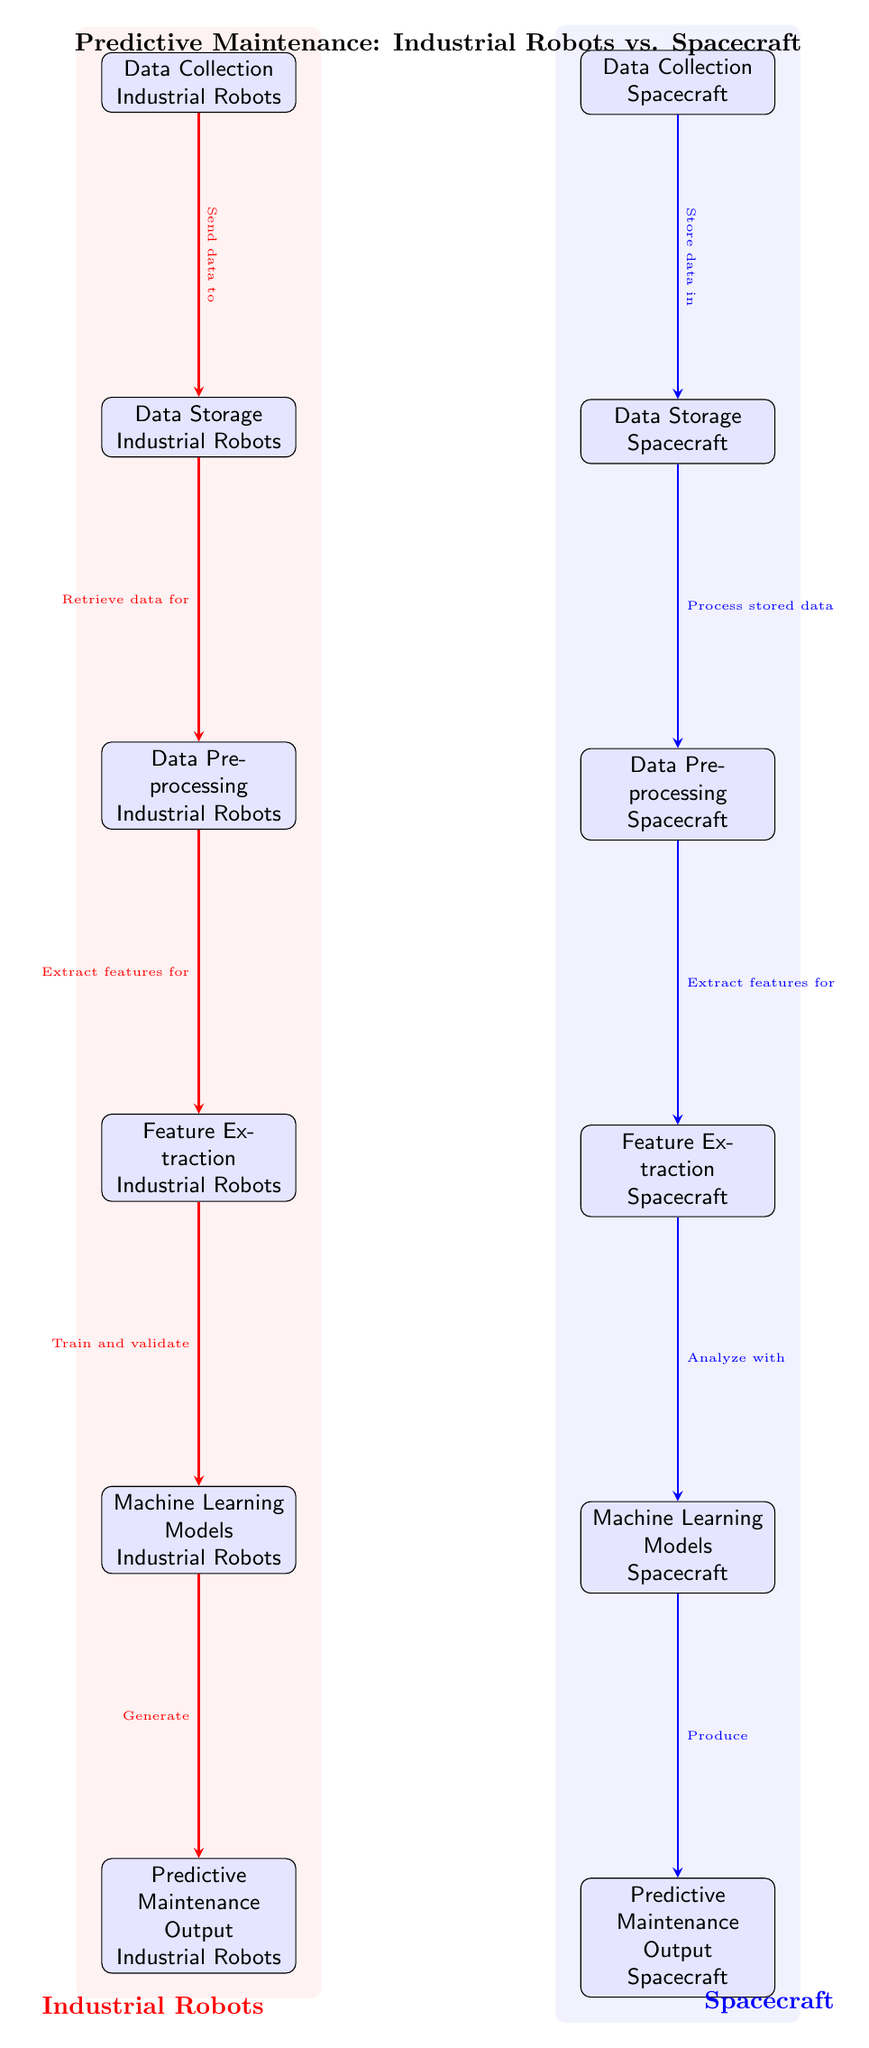What are the two main sections indicated in the diagram? The diagram is divided into two sections, one representing Industrial Robots (in red) and the other representing Spacecraft (in blue), as indicated by the background colors and the section labels.
Answer: Industrial Robots and Spacecraft How many nodes are there for Industrial Robots? Counting the nodes designated for Industrial Robots, there are five: Data Collection, Data Storage, Data Preprocessing, Feature Extraction, and Machine Learning Models.
Answer: Five What is the final output for Spacecraft? The final output node for Spacecraft is labeled as "Predictive Maintenance Output Spacecraft," which clearly indicates the result of the process for that section.
Answer: Predictive Maintenance Output Spacecraft What process immediately follows data storage in Industrial Robots? The process that immediately follows Data Storage for Industrial Robots is Data Preprocessing, which is directly connected to the storage node according to the flow of the diagram.
Answer: Data Preprocessing Which node produces the predictive maintenance output for Industrial Robots? The node that produces the predictive maintenance output for Industrial Robots is "Machine Learning Models Industrial Robots," which generates the output.
Answer: Machine Learning Models Industrial Robots Explain the relationship between Feature Extraction and Machine Learning Models in Spacecraft. In the Spacecraft section, Feature Extraction precedes the Machine Learning Models, indicating that the output from Feature Extraction is necessary for analyzing and training the Machine Learning Models in the predictive maintenance process.
Answer: Feature Extraction leads to Machine Learning Models How many total edges connect the nodes of Industrial Robots? Counting the edges that connect the nodes for Industrial Robots, there are five directed edges shown in red, indicating the flow of the whole predictive maintenance process for Industrial Robots.
Answer: Five Which two processes share a similar flow direction in both sections? The processes of Data Preprocessing and Feature Extraction share a similar flow direction in both Industrial Robots and Spacecraft, as both processes extract and prepare data for the Machine Learning Models that follow.
Answer: Data Preprocessing and Feature Extraction What is the color scheme used to represent Industrial Robots in the diagram? Industrial Robots are represented in red throughout the nodes and the background, which differentiates it clearly from the Spacecraft section.
Answer: Red 